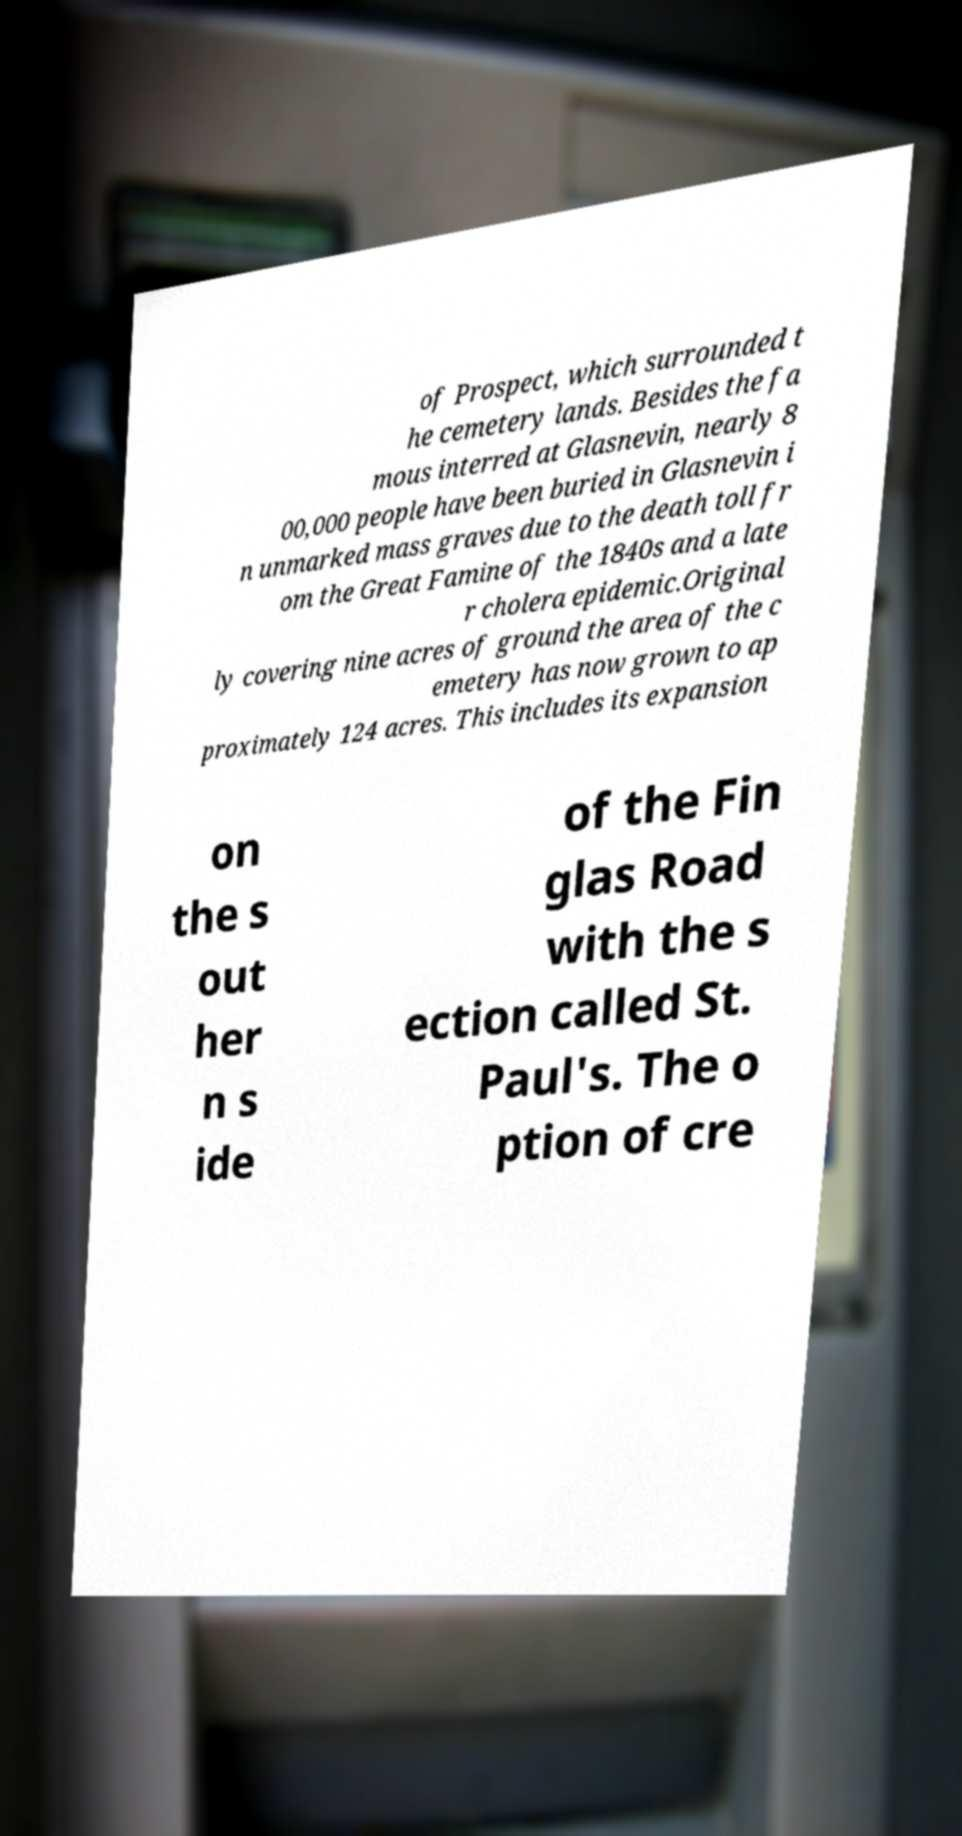There's text embedded in this image that I need extracted. Can you transcribe it verbatim? of Prospect, which surrounded t he cemetery lands. Besides the fa mous interred at Glasnevin, nearly 8 00,000 people have been buried in Glasnevin i n unmarked mass graves due to the death toll fr om the Great Famine of the 1840s and a late r cholera epidemic.Original ly covering nine acres of ground the area of the c emetery has now grown to ap proximately 124 acres. This includes its expansion on the s out her n s ide of the Fin glas Road with the s ection called St. Paul's. The o ption of cre 